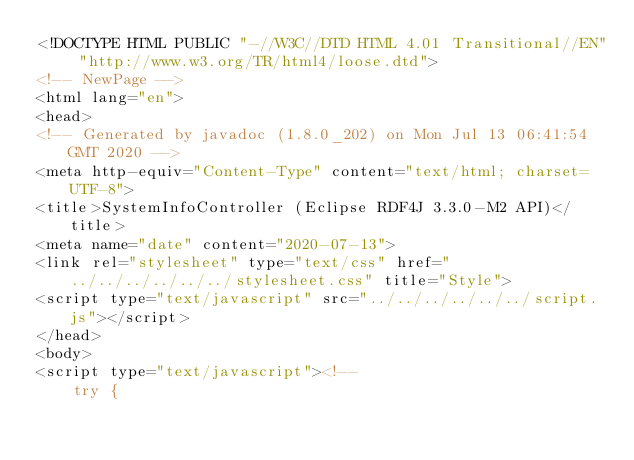Convert code to text. <code><loc_0><loc_0><loc_500><loc_500><_HTML_><!DOCTYPE HTML PUBLIC "-//W3C//DTD HTML 4.01 Transitional//EN" "http://www.w3.org/TR/html4/loose.dtd">
<!-- NewPage -->
<html lang="en">
<head>
<!-- Generated by javadoc (1.8.0_202) on Mon Jul 13 06:41:54 GMT 2020 -->
<meta http-equiv="Content-Type" content="text/html; charset=UTF-8">
<title>SystemInfoController (Eclipse RDF4J 3.3.0-M2 API)</title>
<meta name="date" content="2020-07-13">
<link rel="stylesheet" type="text/css" href="../../../../../../stylesheet.css" title="Style">
<script type="text/javascript" src="../../../../../../script.js"></script>
</head>
<body>
<script type="text/javascript"><!--
    try {</code> 